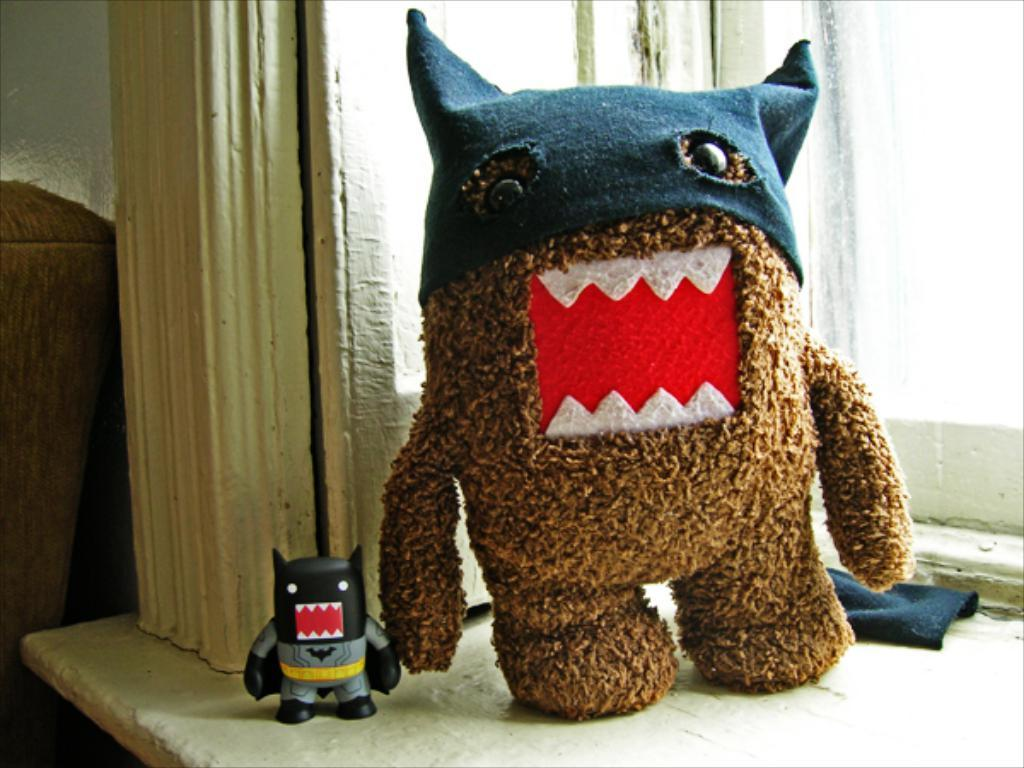How many toys are present in the image? There are two toys in the image. What colors can be seen on the toys? The toys have brown, red, white, black, and ash colors. Where are the toys located in the image? The toys are on a table. What is located next to the table? There is a cloth next to the table. What can be seen to the right of the image? There is a window visible to the right of the image. How many tomatoes are on the table in the image? There are no tomatoes present in the image; it only features two toys. Can you see any adjustments being made to the toys in the image? There is no indication of any adjustments being made to the toys in the image. 